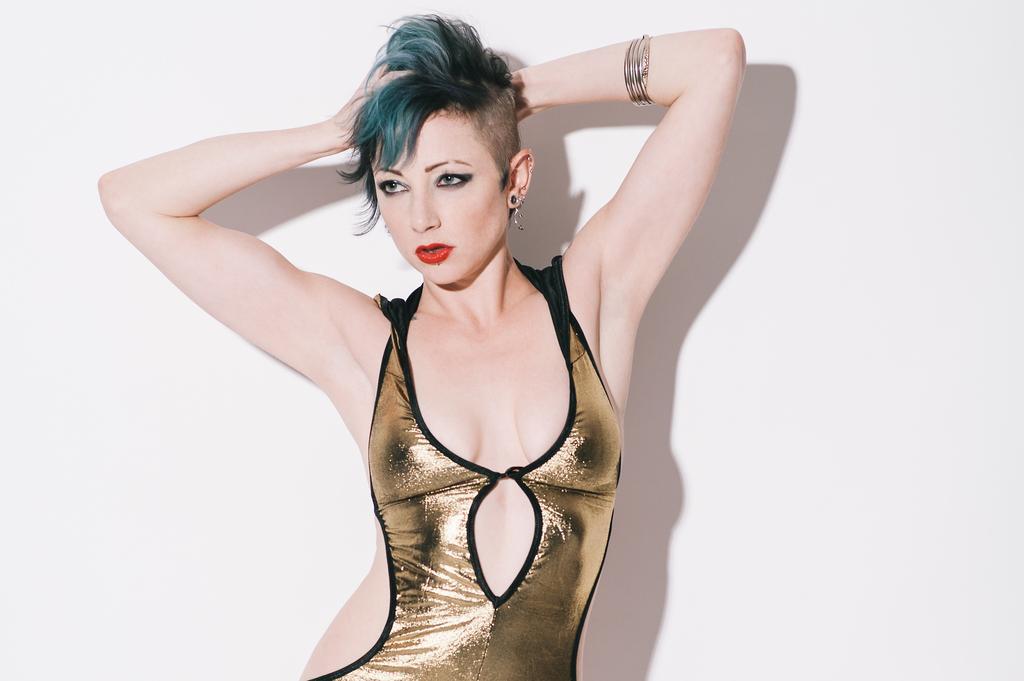Could you give a brief overview of what you see in this image? In this image I can see a woman is standing in the front and I can see she is wearing golden colour dress. In the background I can see shadow of her and the wall. 